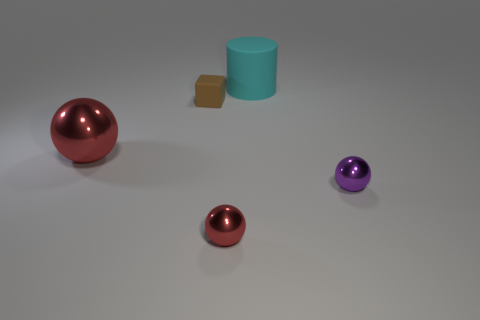Add 3 tiny purple metal things. How many objects exist? 8 Subtract all balls. How many objects are left? 2 Add 3 large red metallic balls. How many large red metallic balls are left? 4 Add 2 small metallic things. How many small metallic things exist? 4 Subtract 0 red blocks. How many objects are left? 5 Subtract all small yellow shiny cylinders. Subtract all tiny purple metallic spheres. How many objects are left? 4 